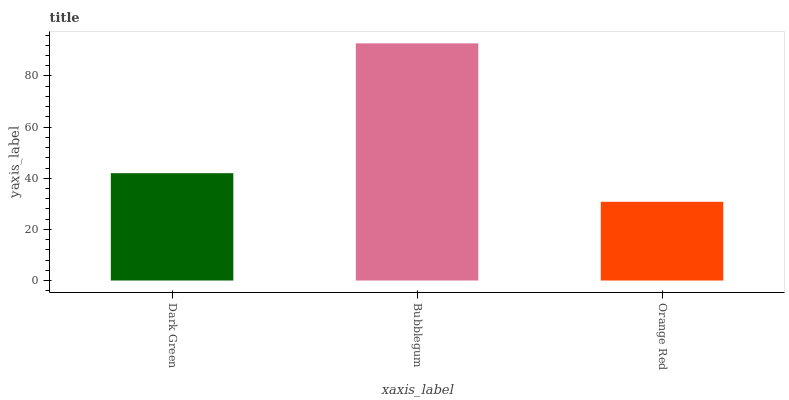Is Orange Red the minimum?
Answer yes or no. Yes. Is Bubblegum the maximum?
Answer yes or no. Yes. Is Bubblegum the minimum?
Answer yes or no. No. Is Orange Red the maximum?
Answer yes or no. No. Is Bubblegum greater than Orange Red?
Answer yes or no. Yes. Is Orange Red less than Bubblegum?
Answer yes or no. Yes. Is Orange Red greater than Bubblegum?
Answer yes or no. No. Is Bubblegum less than Orange Red?
Answer yes or no. No. Is Dark Green the high median?
Answer yes or no. Yes. Is Dark Green the low median?
Answer yes or no. Yes. Is Bubblegum the high median?
Answer yes or no. No. Is Orange Red the low median?
Answer yes or no. No. 